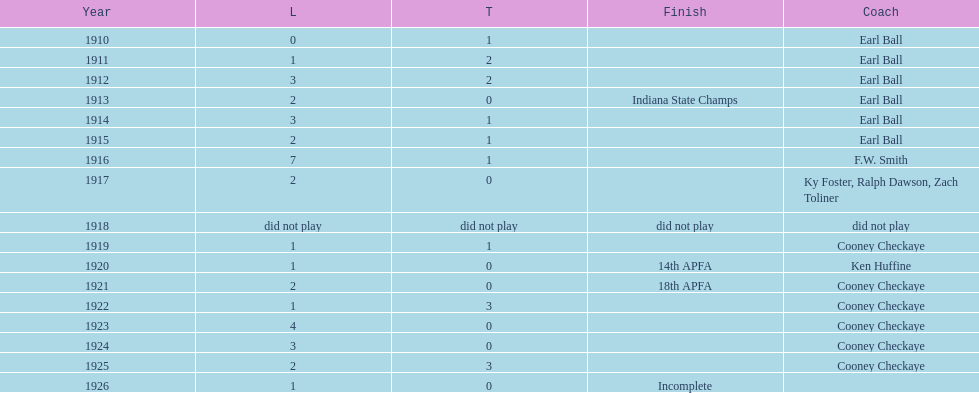The muncie flyers played from 1910 to 1925 in all but one of those years. which year did the flyers not play? 1918. 